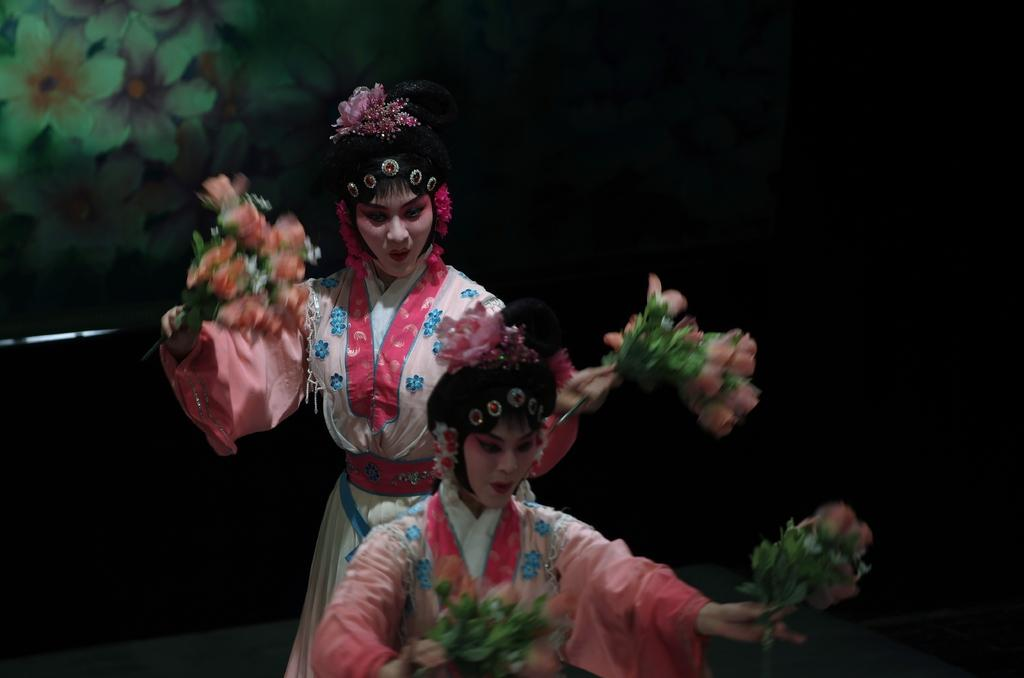How many people are in the image? There are two persons in the image. What are the persons doing in the image? The persons are dancing. What are the persons holding in their hands? The persons are holding flower bouquets in their hands. What can be seen in the background of the image? There are flowers visible in the background of the image. What type of system is being used by the persons to protect themselves from the rain in the image? There is no rain or umbrella present in the image, and therefore no system for protection is needed. 